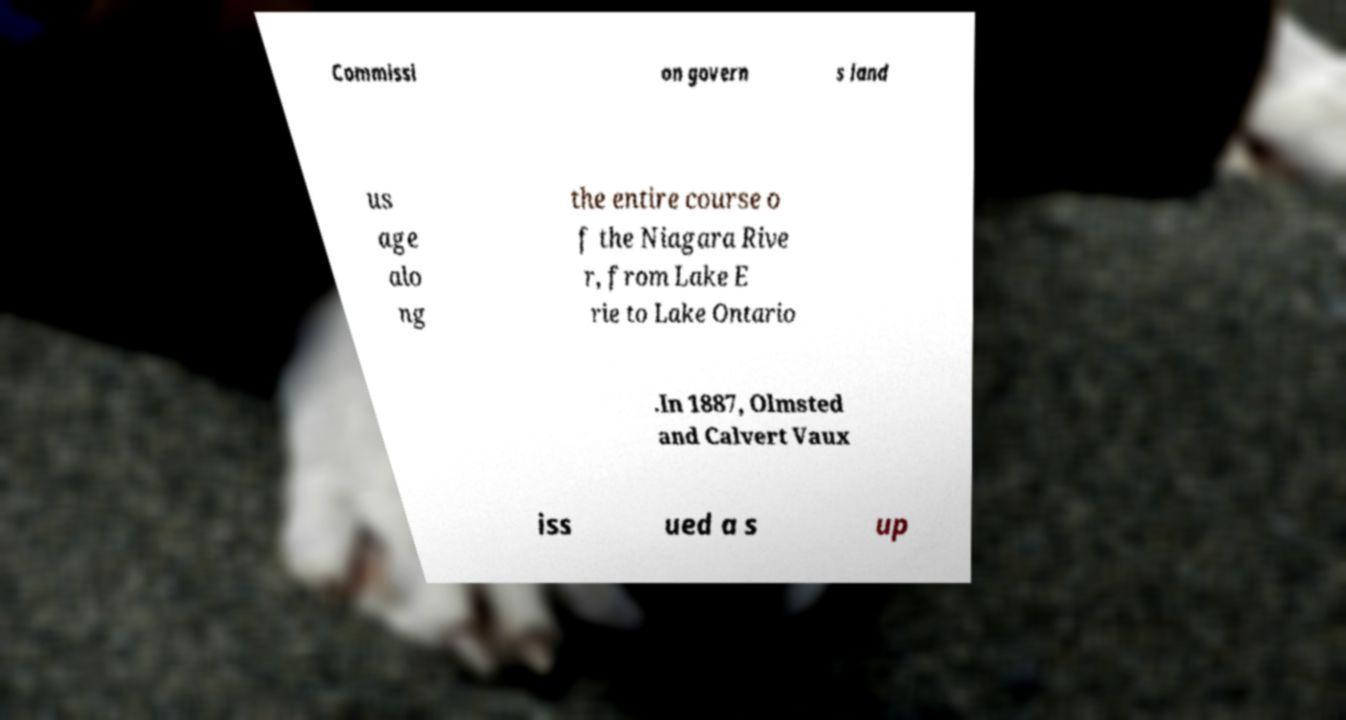For documentation purposes, I need the text within this image transcribed. Could you provide that? Commissi on govern s land us age alo ng the entire course o f the Niagara Rive r, from Lake E rie to Lake Ontario .In 1887, Olmsted and Calvert Vaux iss ued a s up 